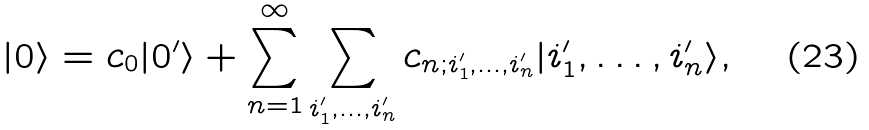Convert formula to latex. <formula><loc_0><loc_0><loc_500><loc_500>| 0 \rangle = c _ { 0 } | 0 ^ { \prime } \rangle + \sum _ { n = 1 } ^ { \infty } \sum _ { i ^ { \prime } _ { 1 } , \dots , i ^ { \prime } _ { n } } c _ { n ; i ^ { \prime } _ { 1 } , \dots , i ^ { \prime } _ { n } } | i ^ { \prime } _ { 1 } , \dots , i ^ { \prime } _ { n } \rangle ,</formula> 